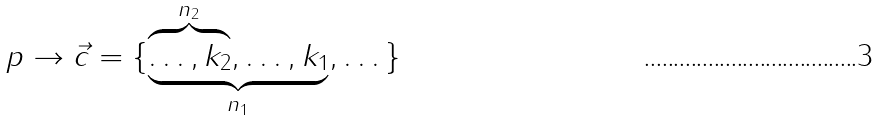<formula> <loc_0><loc_0><loc_500><loc_500>p \to \vec { c } = \{ \underbrace { \overbrace { \dots , k _ { 2 } } ^ { n _ { 2 } } , \dots , k _ { 1 } } _ { n _ { 1 } } , \dots \}</formula> 